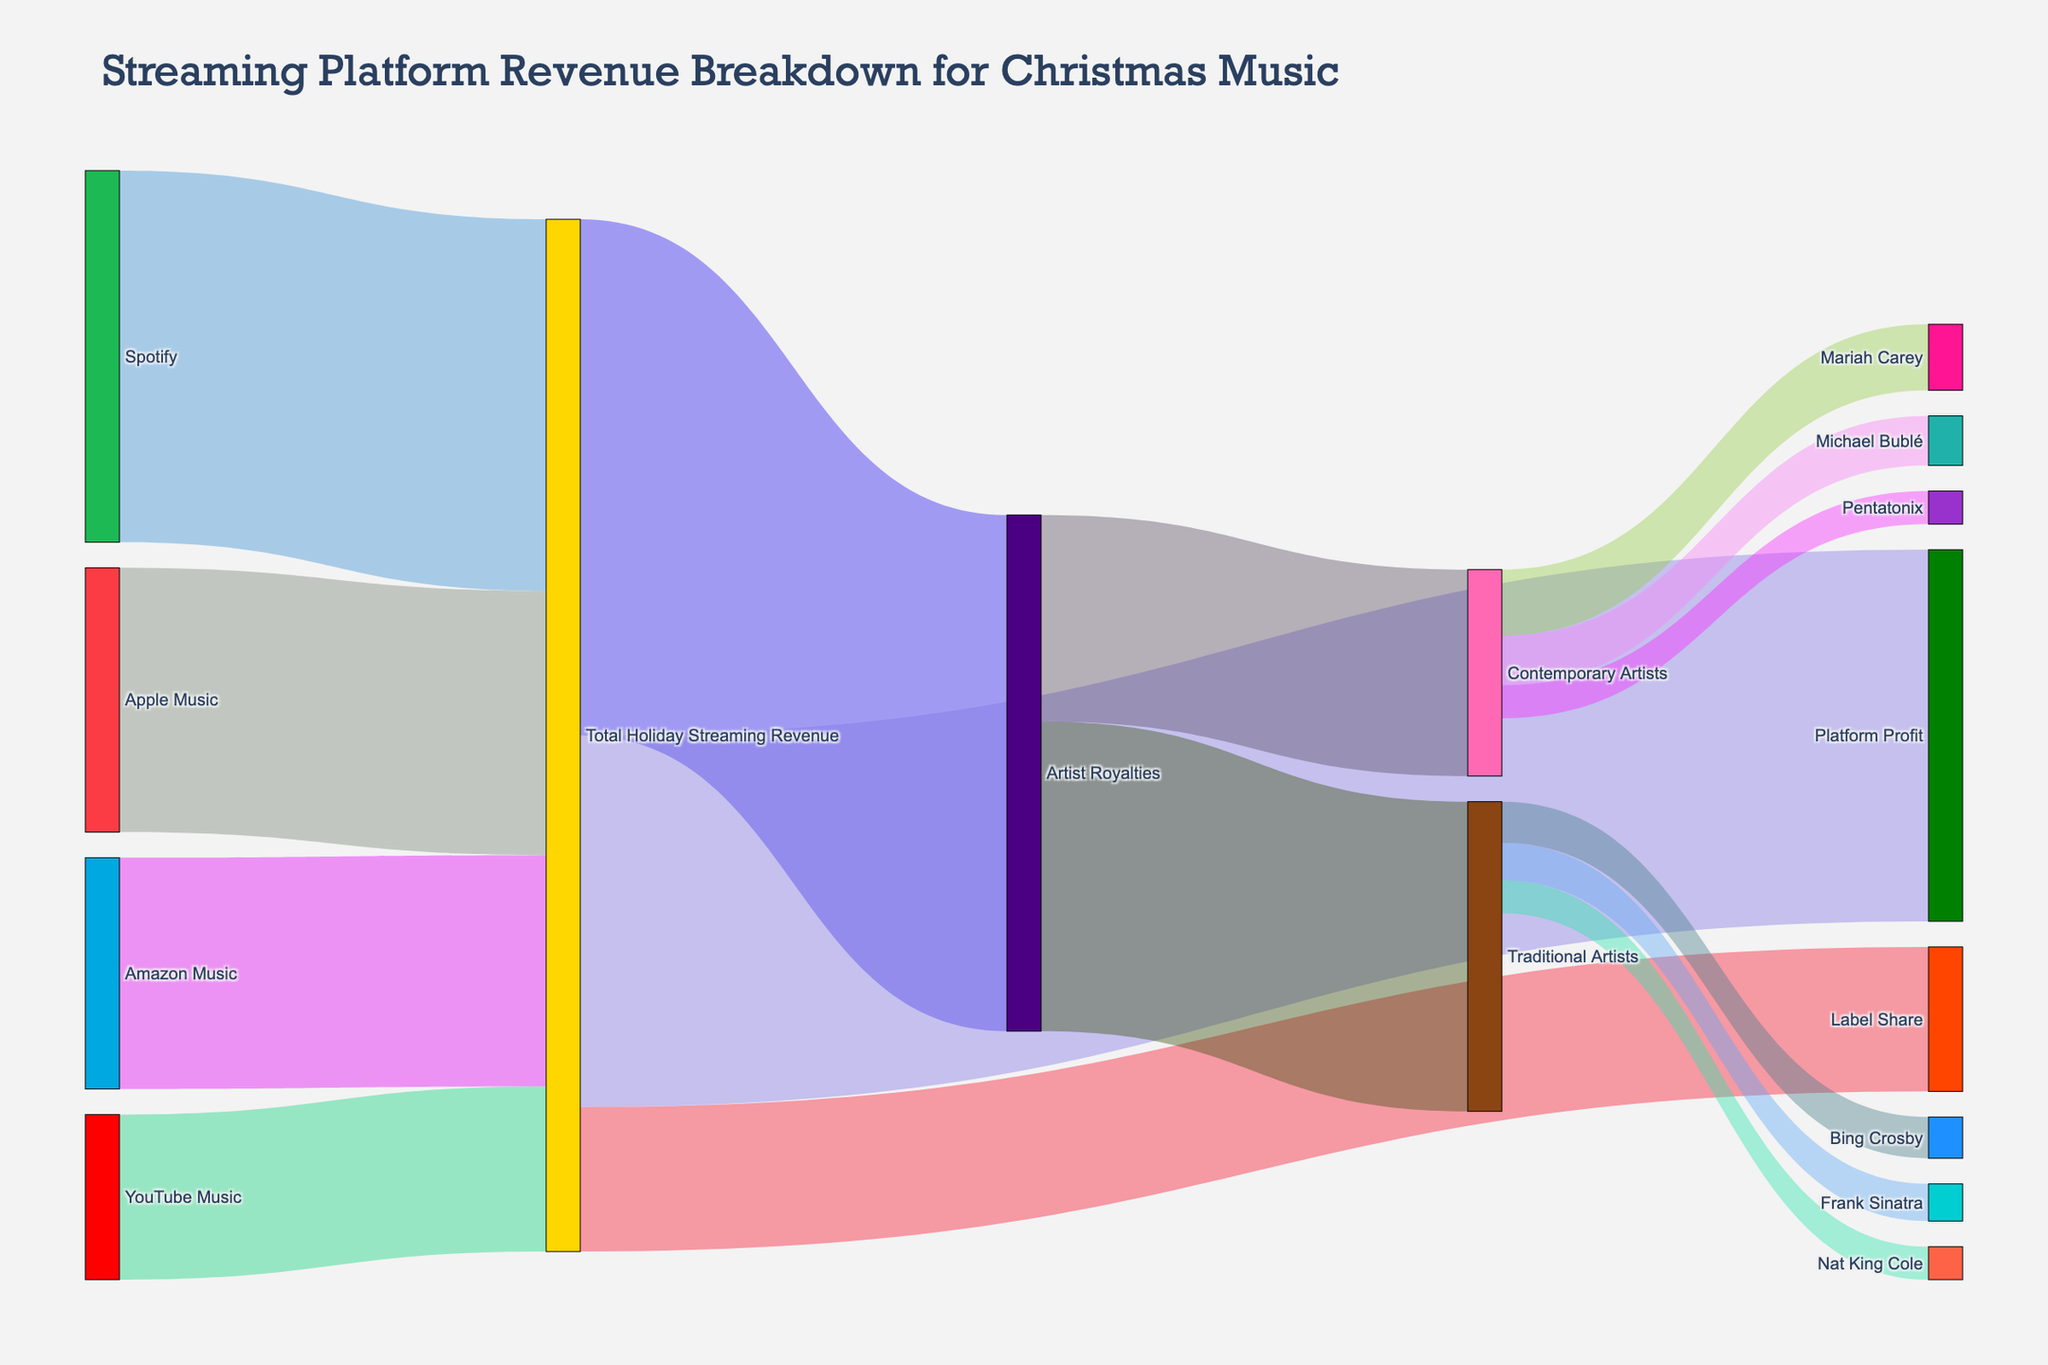which streaming platform generates the highest revenue during the holiday season for christmas music? The highest value connected to "Total Holiday Streaming Revenue" from streaming platforms is observed. "Spotify" has the largest value with 450 million.
Answer: Spotify how much total holiday streaming revenue is generated by all platforms combined? Adding up all the revenue values from "Spotify", "Apple Music", "Amazon Music", and "YouTube Music" results in 450 million + 320 million + 280 million + 200 million = 1.25 billion.
Answer: 1.25 billion which group of artists receives more from artist royalties, traditional artists or contemporary artists? Compare the values connected to "Artist Royalties". Traditional Artists have 375 million, while Contemporary Artists have 250 million. 375 million is greater.
Answer: Traditional Artists how much do the top three contemporary christmas artists collectively earn from artist royalties? Sum the values of Mariah Carey, Michael Bublé, and Pentatonix. 80 million + 60 million + 40 million = 180 million.
Answer: 180 million what is the difference in revenue between artist royalties and platform profit? Subtract Platform Profit from Artist Royalties: 625 million - 450 million = 175 million.
Answer: 175 million which artist earns the least from traditional artists group? Compare the values of Bing Crosby, Frank Sinatra, and Nat King Cole. Nat King Cole has the lowest value at 40 million.
Answer: Nat King Cole how much profit do platforms make from christmas music streaming? Refer to the value labeled "Platform Profit" connected to "Total Holiday Streaming Revenue": 450 million.
Answer: 450 million how does the label share compare to the artist royalties? Compare the values connected to "Total Holiday Streaming Revenue". Artist Royalties are 625 million and Label Share is 175 million. Artist Royalties are higher.
Answer: Artist Royalties what percentage of total holiday streaming revenue is from spotify? Divide Spotify revenue by the sum of all platform revenues then multiply by 100. (450 million/1.25 billion) * 100 = 36%.
Answer: 36% considering all the artists listed, who earns the most from christmas music streaming royalties? Compare the values for all listed artists under Traditional and Contemporary Artists. Mariah Carey has the highest value at 80 million.
Answer: Mariah Carey 